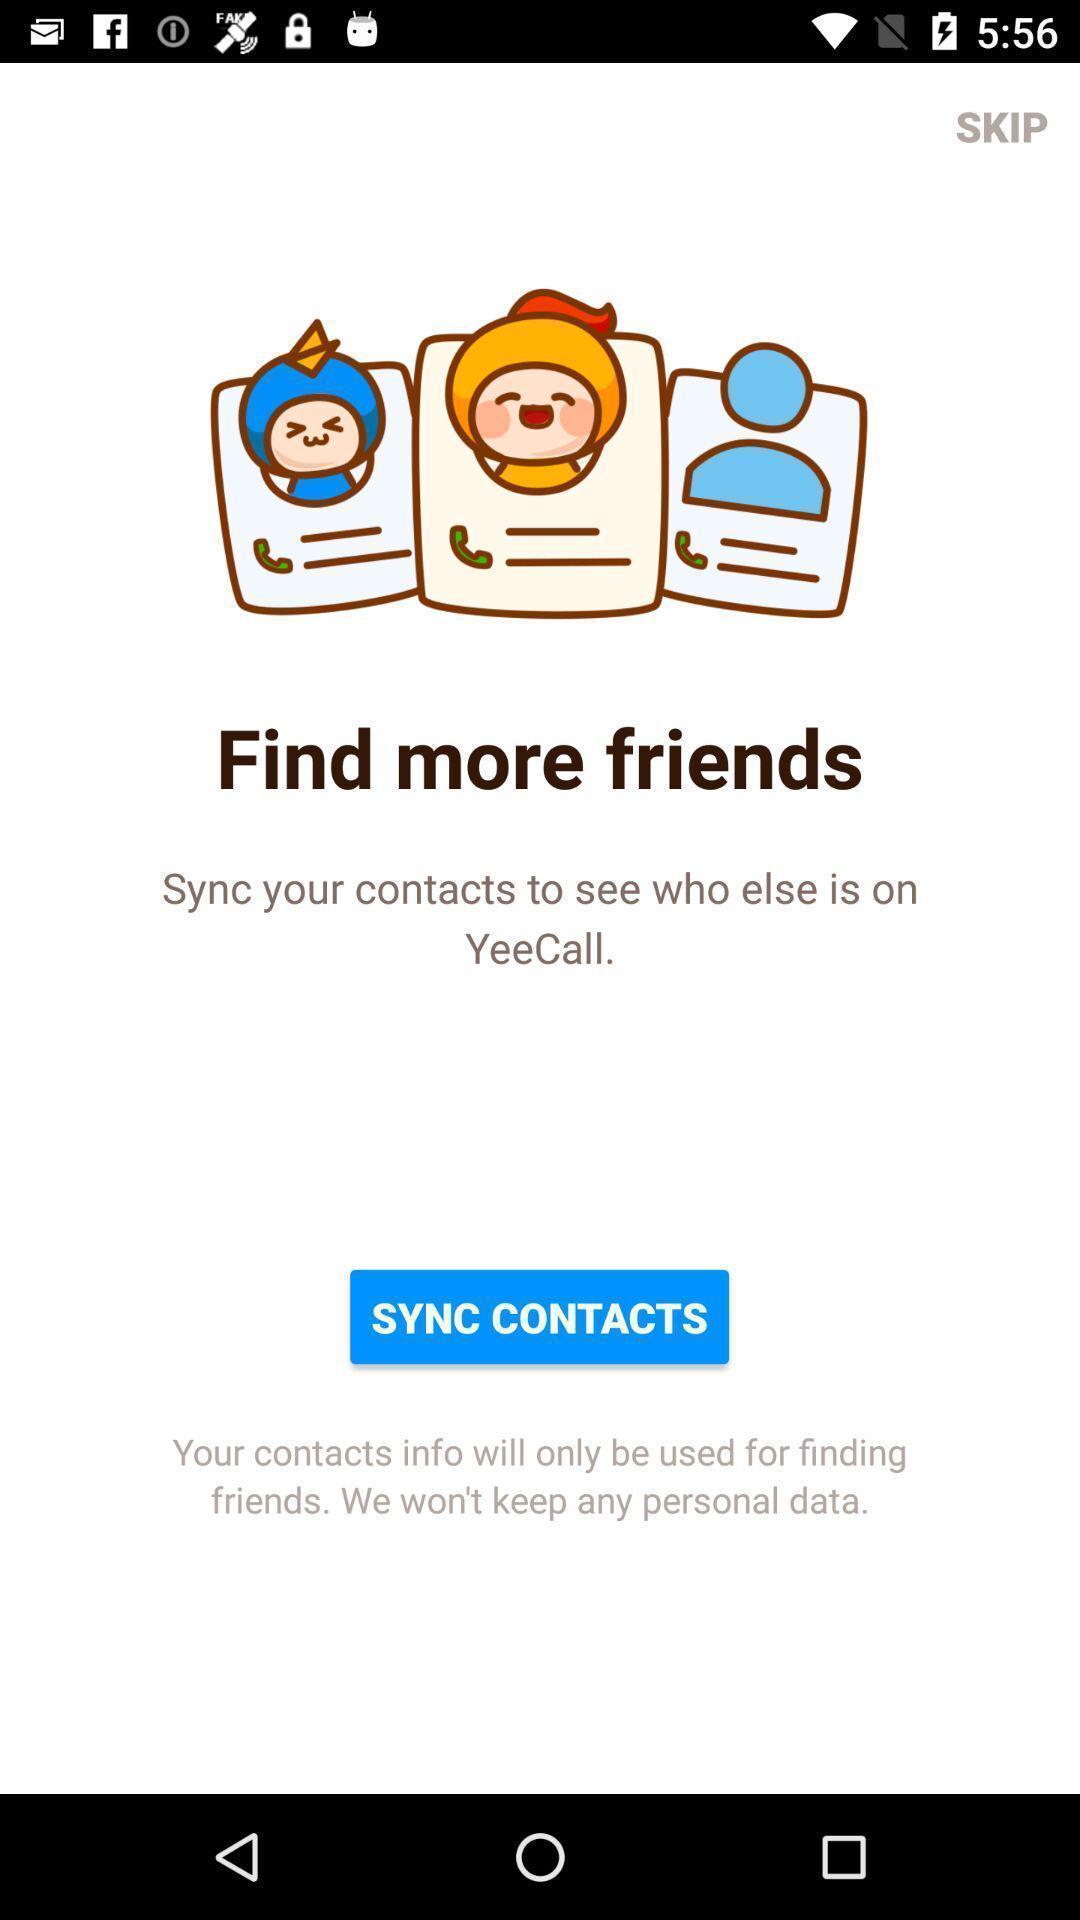Provide a detailed account of this screenshot. Page to sync contacts to find friends. 